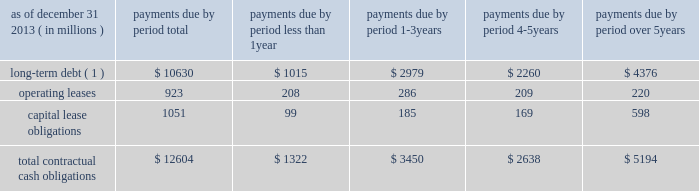Management 2019s discussion and analysis of financial condition and results of operations ( continued ) the npr is generally consistent with the basel committee 2019s lcr .
However , it includes certain more stringent requirements , including an accelerated implementation time line and modifications to the definition of high-quality liquid assets and expected outflow assumptions .
We continue to analyze the proposed rules and analyze their impact as well as develop strategies for compliance .
The principles of the lcr are consistent with our liquidity management framework ; however , the specific calibrations of various elements within the final lcr rule , such as the eligibility of assets as hqla , operational deposit requirements and net outflow requirements could have a material effect on our liquidity , funding and business activities , including the management and composition of our investment securities portfolio and our ability to extend committed contingent credit facilities to our clients .
In january 2014 , the basel committee released a revised proposal with respect to the net stable funding ratio , or nsfr , which will establish a one-year liquidity standard representing the proportion of long-term assets funded by long-term stable funding , scheduled for global implementation in 2018 .
The revised nsfr has made some favorable changes regarding the treatment of operationally linked deposits and a reduction in the funding required for certain securities .
However , we continue to review the specifics of the basel committee's release and will be evaluating the u.s .
Implementation of this standard to analyze the impact and develop strategies for compliance .
U.s .
Banking regulators have not yet issued a proposal to implement the nsfr .
Contractual cash obligations and other commitments the table presents our long-term contractual cash obligations , in total and by period due as of december 31 , 2013 .
These obligations were recorded in our consolidated statement of condition as of that date , except for operating leases and the interest portions of long-term debt and capital leases .
Contractual cash obligations .
( 1 ) long-term debt excludes capital lease obligations ( presented as a separate line item ) and the effect of interest-rate swaps .
Interest payments were calculated at the stated rate with the exception of floating-rate debt , for which payments were calculated using the indexed rate in effect as of december 31 , 2013 .
The table above does not include obligations which will be settled in cash , primarily in less than one year , such as client deposits , federal funds purchased , securities sold under repurchase agreements and other short-term borrowings .
Additional information about deposits , federal funds purchased , securities sold under repurchase agreements and other short-term borrowings is provided in notes 8 and 9 to the consolidated financial statements included under item 8 of this form 10-k .
The table does not include obligations related to derivative instruments because the derivative-related amounts recorded in our consolidated statement of condition as of december 31 , 2013 did not represent the amounts that may ultimately be paid under the contracts upon settlement .
Additional information about our derivative instruments is provided in note 16 to the consolidated financial statements included under item 8 of this form 10-k .
We have obligations under pension and other post-retirement benefit plans , more fully described in note 19 to the consolidated financial statements included under item 8 of this form 10-k , which are not included in the above table .
Additional information about contractual cash obligations related to long-term debt and operating and capital leases is provided in notes 10 and 20 to the consolidated financial statements included under item 8 of this form 10-k .
Our consolidated statement of cash flows , also included under item 8 of this form 10-k , provides additional liquidity information .
The following table presents our commitments , other than the contractual cash obligations presented above , in total and by duration as of december 31 , 2013 .
These commitments were not recorded in our consolidated statement of condition as of that date. .
What percent of total contractual obligations is long term debt? 
Computations: (10630 / 12604)
Answer: 0.84338. 